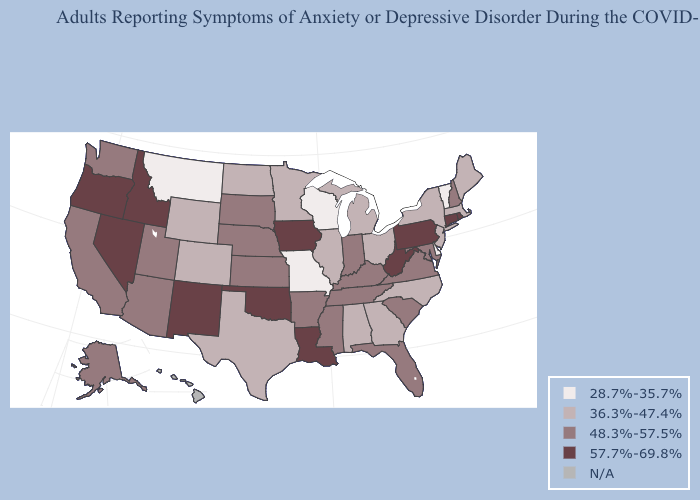Name the states that have a value in the range 36.3%-47.4%?
Keep it brief. Alabama, Colorado, Georgia, Illinois, Maine, Massachusetts, Michigan, Minnesota, New Jersey, New York, North Carolina, North Dakota, Ohio, Texas, Wyoming. Among the states that border Nevada , does Arizona have the highest value?
Write a very short answer. No. Does the map have missing data?
Give a very brief answer. Yes. What is the value of Montana?
Concise answer only. 28.7%-35.7%. Is the legend a continuous bar?
Quick response, please. No. What is the value of Iowa?
Keep it brief. 57.7%-69.8%. Name the states that have a value in the range 28.7%-35.7%?
Give a very brief answer. Delaware, Missouri, Montana, Vermont, Wisconsin. What is the value of Montana?
Quick response, please. 28.7%-35.7%. Which states have the lowest value in the Northeast?
Keep it brief. Vermont. What is the lowest value in the USA?
Quick response, please. 28.7%-35.7%. Among the states that border South Dakota , which have the highest value?
Concise answer only. Iowa. Does Alaska have the highest value in the West?
Short answer required. No. Which states have the highest value in the USA?
Answer briefly. Connecticut, Idaho, Iowa, Louisiana, Nevada, New Mexico, Oklahoma, Oregon, Pennsylvania, Rhode Island, West Virginia. Which states hav the highest value in the MidWest?
Answer briefly. Iowa. 